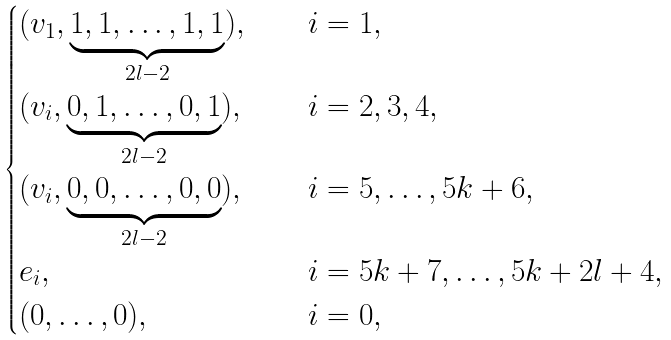<formula> <loc_0><loc_0><loc_500><loc_500>\begin{cases} ( v _ { 1 } , \underbrace { 1 , 1 , \dots , 1 , 1 } _ { 2 l - 2 } ) , \quad & i = 1 , \\ ( v _ { i } , \underbrace { 0 , 1 , \dots , 0 , 1 } _ { 2 l - 2 } ) , & i = 2 , 3 , 4 , \\ ( v _ { i } , \underbrace { 0 , 0 , \dots , 0 , 0 } _ { 2 l - 2 } ) , & i = 5 , \dots , 5 k + 6 , \\ { e } _ { i } , & i = 5 k + 7 , \dots , 5 k + 2 l + 4 , \\ ( 0 , \dots , 0 ) , & i = 0 , \end{cases}</formula> 